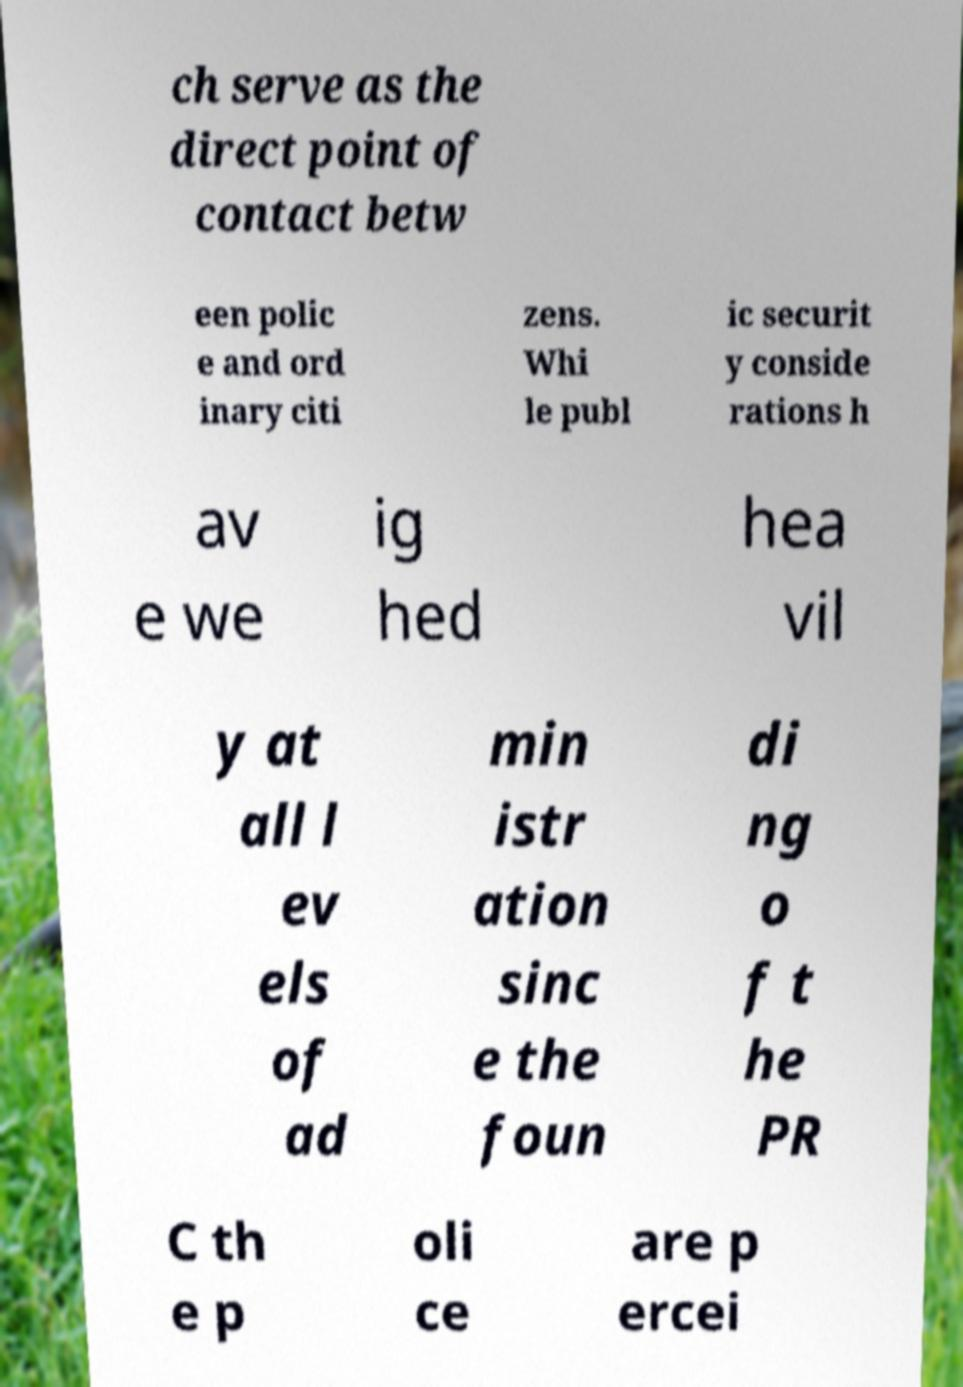Could you assist in decoding the text presented in this image and type it out clearly? ch serve as the direct point of contact betw een polic e and ord inary citi zens. Whi le publ ic securit y conside rations h av e we ig hed hea vil y at all l ev els of ad min istr ation sinc e the foun di ng o f t he PR C th e p oli ce are p ercei 